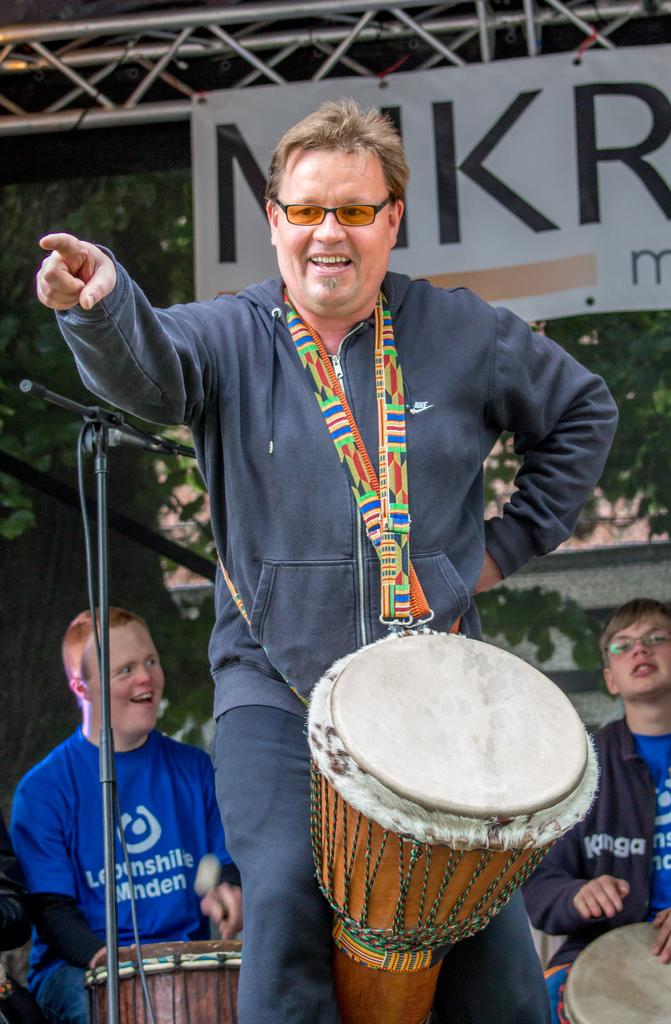What is the main subject of the image? There is a man standing in the center of the image. What is the man doing in the image? The man is smiling and holding a drum. What can be seen in the background of the image? There is a banner, trees, a microphone, and two persons sitting on chairs in the background of the image. Can you see an alley, a ball, or an owl in the image? No, there is no alley, ball, or owl present in the image. 